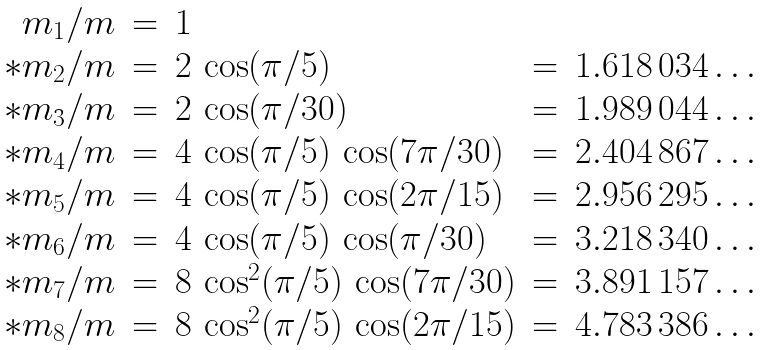Convert formula to latex. <formula><loc_0><loc_0><loc_500><loc_500>\begin{array} { r c l c l } { { m _ { 1 } / m } } & { = } & { 1 } \\ { { * m _ { 2 } / m } } & { = } & { 2 \, \cos ( \pi / 5 ) } & { = } & { 1 . 6 1 8 \, 0 3 4 \dots } \\ { { * m _ { 3 } / m } } & { = } & { 2 \, \cos ( \pi / 3 0 ) } & { = } & { 1 . 9 8 9 \, 0 4 4 \dots } \\ { { * m _ { 4 } / m } } & { = } & { 4 \, \cos ( \pi / 5 ) \, \cos ( 7 \pi / 3 0 ) } & { = } & { 2 . 4 0 4 \, 8 6 7 \dots } \\ { { * m _ { 5 } / m } } & { = } & { 4 \, \cos ( \pi / 5 ) \, \cos ( 2 \pi / 1 5 ) } & { = } & { 2 . 9 5 6 \, 2 9 5 \dots } \\ { { * m _ { 6 } / m } } & { = } & { 4 \, \cos ( \pi / 5 ) \, \cos ( \pi / 3 0 ) } & { = } & { 3 . 2 1 8 \, 3 4 0 \dots } \\ { { * m _ { 7 } / m } } & { = } & { { 8 \, \cos ^ { 2 } ( \pi / 5 ) \, \cos ( 7 \pi / 3 0 ) } } & { = } & { 3 . 8 9 1 \, 1 5 7 \dots } \\ { { * m _ { 8 } / m } } & { = } & { { 8 \, \cos ^ { 2 } ( \pi / 5 ) \, \cos ( 2 \pi / 1 5 ) } } & { = } & { 4 . 7 8 3 \, 3 8 6 \dots } \end{array}</formula> 